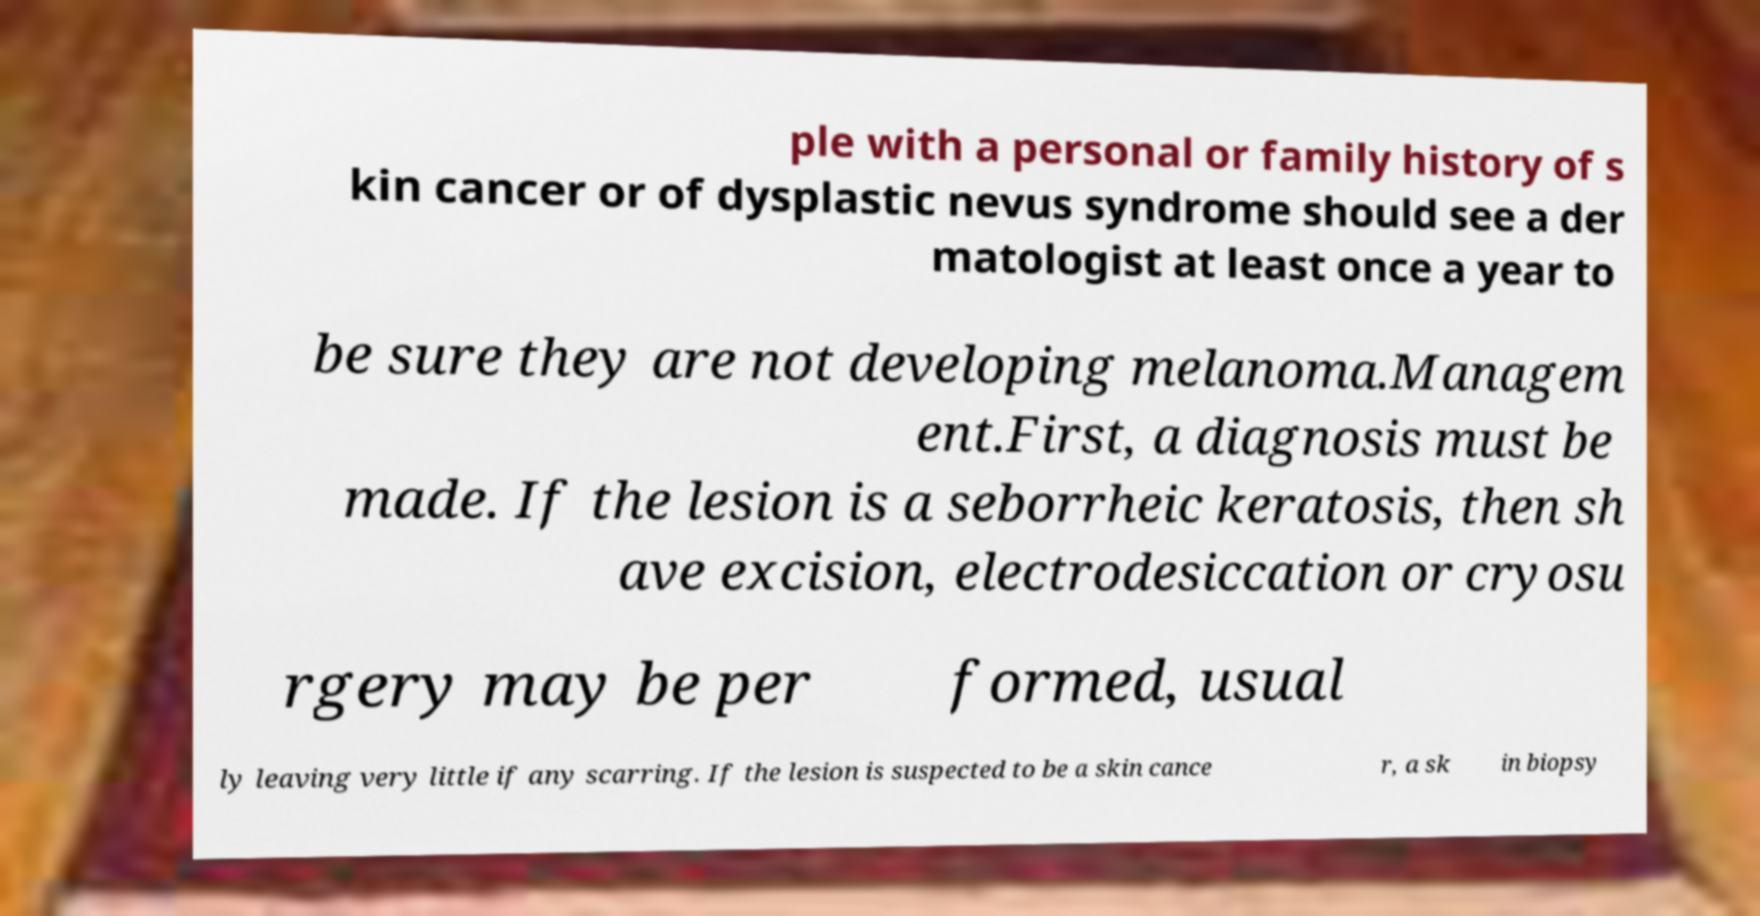I need the written content from this picture converted into text. Can you do that? ple with a personal or family history of s kin cancer or of dysplastic nevus syndrome should see a der matologist at least once a year to be sure they are not developing melanoma.Managem ent.First, a diagnosis must be made. If the lesion is a seborrheic keratosis, then sh ave excision, electrodesiccation or cryosu rgery may be per formed, usual ly leaving very little if any scarring. If the lesion is suspected to be a skin cance r, a sk in biopsy 